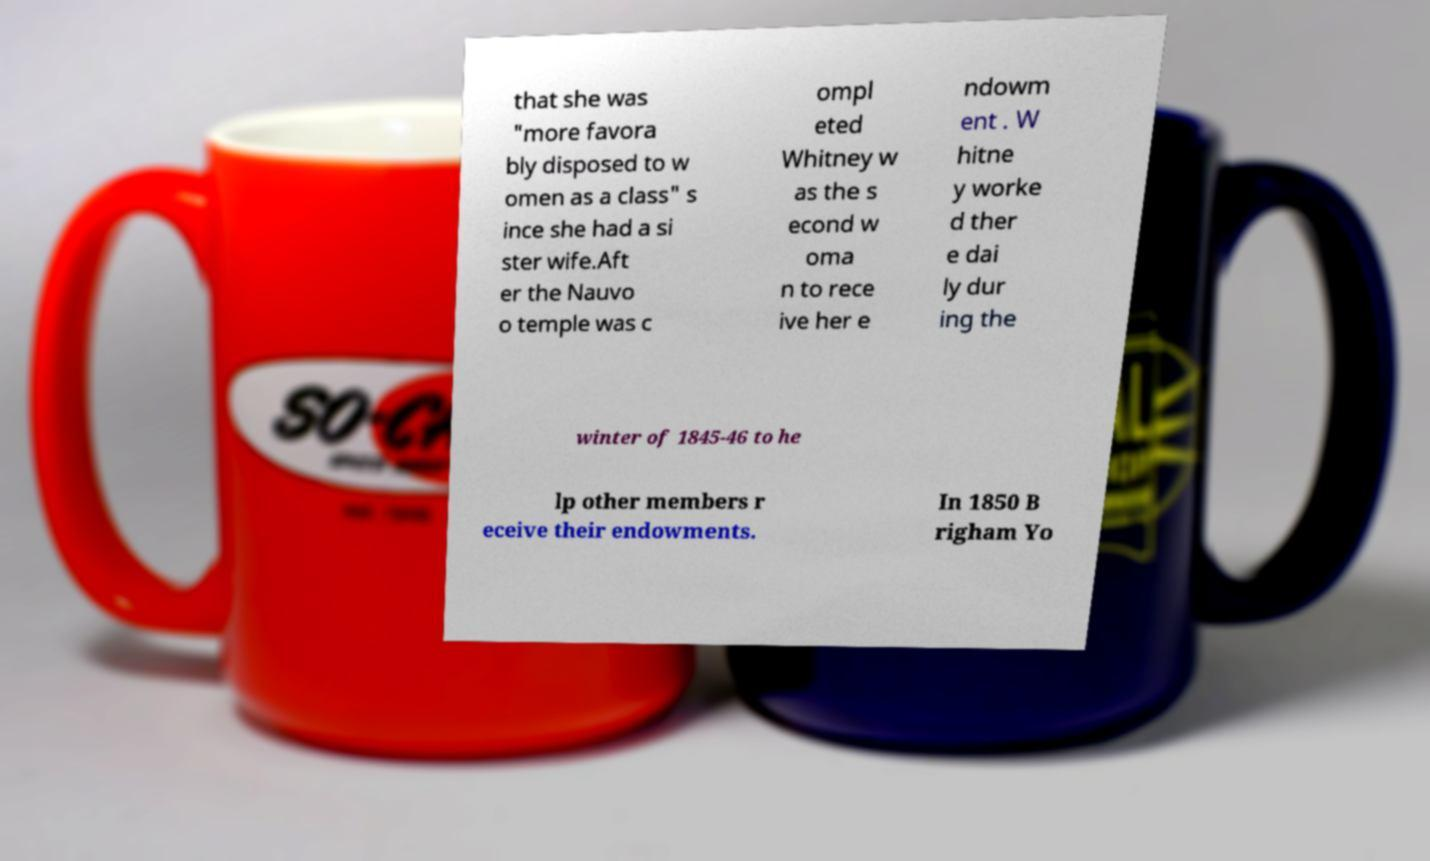For documentation purposes, I need the text within this image transcribed. Could you provide that? that she was "more favora bly disposed to w omen as a class" s ince she had a si ster wife.Aft er the Nauvo o temple was c ompl eted Whitney w as the s econd w oma n to rece ive her e ndowm ent . W hitne y worke d ther e dai ly dur ing the winter of 1845-46 to he lp other members r eceive their endowments. In 1850 B righam Yo 